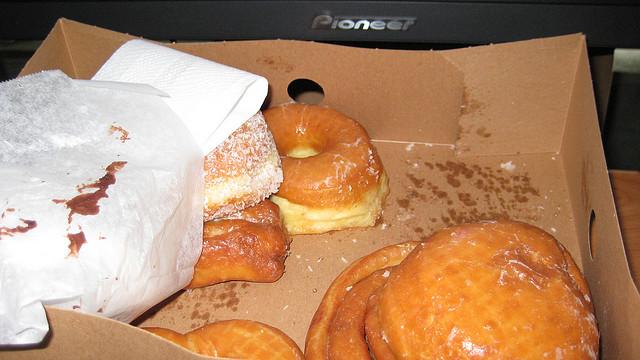Which donut is your favorite?
Give a very brief answer. Glazed. How many donuts do you see?
Give a very brief answer. 8. What color is the box?
Quick response, please. Brown. Are these greasy?
Write a very short answer. Yes. Are these salty foods?
Short answer required. No. 